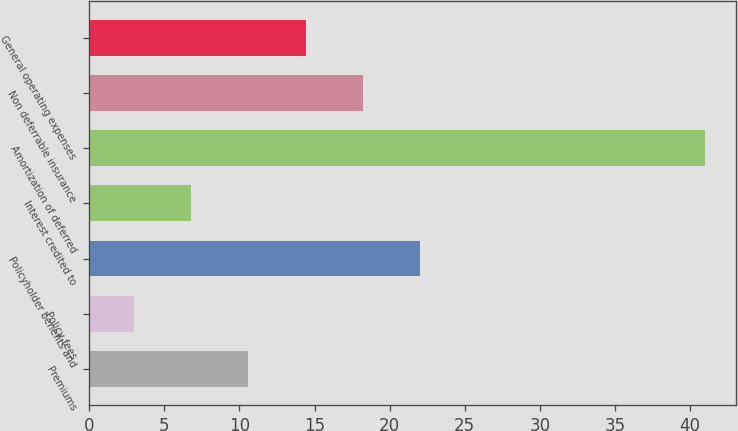Convert chart. <chart><loc_0><loc_0><loc_500><loc_500><bar_chart><fcel>Premiums<fcel>Policy fees<fcel>Policyholder benefits and<fcel>Interest credited to<fcel>Amortization of deferred<fcel>Non deferrable insurance<fcel>General operating expenses<nl><fcel>10.6<fcel>3<fcel>22<fcel>6.8<fcel>41<fcel>18.2<fcel>14.4<nl></chart> 